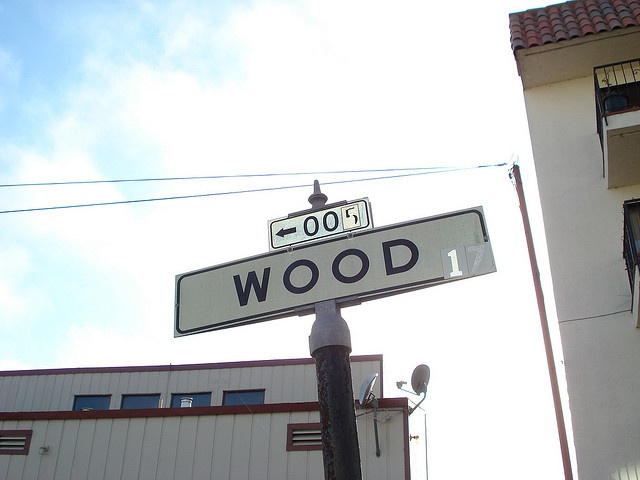Describe the objects in this image and their specific colors. I can see various objects in this image with different colors. 